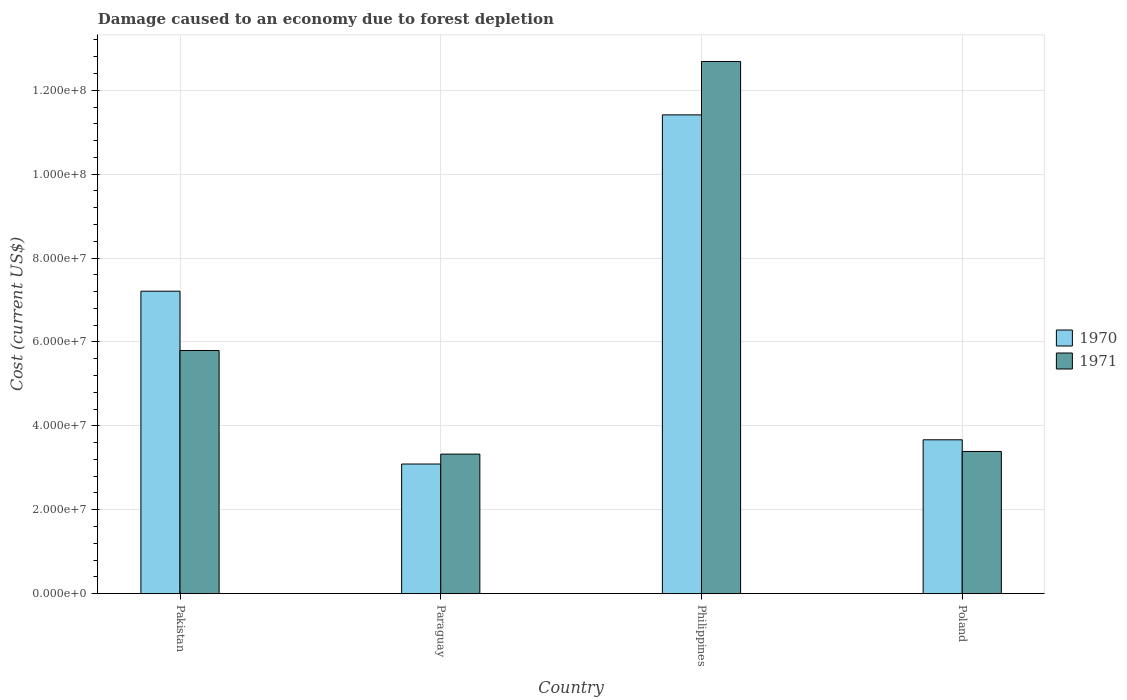Are the number of bars on each tick of the X-axis equal?
Your answer should be very brief. Yes. How many bars are there on the 2nd tick from the left?
Your response must be concise. 2. How many bars are there on the 1st tick from the right?
Provide a short and direct response. 2. What is the label of the 3rd group of bars from the left?
Your answer should be very brief. Philippines. What is the cost of damage caused due to forest depletion in 1971 in Paraguay?
Offer a very short reply. 3.33e+07. Across all countries, what is the maximum cost of damage caused due to forest depletion in 1971?
Provide a short and direct response. 1.27e+08. Across all countries, what is the minimum cost of damage caused due to forest depletion in 1970?
Offer a very short reply. 3.09e+07. In which country was the cost of damage caused due to forest depletion in 1971 minimum?
Keep it short and to the point. Paraguay. What is the total cost of damage caused due to forest depletion in 1971 in the graph?
Ensure brevity in your answer.  2.52e+08. What is the difference between the cost of damage caused due to forest depletion in 1971 in Pakistan and that in Philippines?
Provide a short and direct response. -6.89e+07. What is the difference between the cost of damage caused due to forest depletion in 1970 in Poland and the cost of damage caused due to forest depletion in 1971 in Pakistan?
Provide a succinct answer. -2.13e+07. What is the average cost of damage caused due to forest depletion in 1970 per country?
Make the answer very short. 6.35e+07. What is the difference between the cost of damage caused due to forest depletion of/in 1970 and cost of damage caused due to forest depletion of/in 1971 in Paraguay?
Provide a short and direct response. -2.36e+06. In how many countries, is the cost of damage caused due to forest depletion in 1970 greater than 64000000 US$?
Provide a succinct answer. 2. What is the ratio of the cost of damage caused due to forest depletion in 1970 in Pakistan to that in Philippines?
Offer a very short reply. 0.63. Is the cost of damage caused due to forest depletion in 1970 in Paraguay less than that in Philippines?
Provide a succinct answer. Yes. What is the difference between the highest and the second highest cost of damage caused due to forest depletion in 1971?
Provide a succinct answer. -6.89e+07. What is the difference between the highest and the lowest cost of damage caused due to forest depletion in 1970?
Keep it short and to the point. 8.32e+07. Is the sum of the cost of damage caused due to forest depletion in 1971 in Pakistan and Paraguay greater than the maximum cost of damage caused due to forest depletion in 1970 across all countries?
Keep it short and to the point. No. What does the 1st bar from the left in Pakistan represents?
Give a very brief answer. 1970. How many bars are there?
Keep it short and to the point. 8. Are all the bars in the graph horizontal?
Give a very brief answer. No. How many countries are there in the graph?
Your answer should be compact. 4. What is the difference between two consecutive major ticks on the Y-axis?
Offer a terse response. 2.00e+07. Are the values on the major ticks of Y-axis written in scientific E-notation?
Give a very brief answer. Yes. How are the legend labels stacked?
Offer a terse response. Vertical. What is the title of the graph?
Ensure brevity in your answer.  Damage caused to an economy due to forest depletion. What is the label or title of the X-axis?
Give a very brief answer. Country. What is the label or title of the Y-axis?
Give a very brief answer. Cost (current US$). What is the Cost (current US$) in 1970 in Pakistan?
Your answer should be very brief. 7.21e+07. What is the Cost (current US$) of 1971 in Pakistan?
Provide a short and direct response. 5.80e+07. What is the Cost (current US$) of 1970 in Paraguay?
Provide a succinct answer. 3.09e+07. What is the Cost (current US$) in 1971 in Paraguay?
Provide a succinct answer. 3.33e+07. What is the Cost (current US$) of 1970 in Philippines?
Offer a very short reply. 1.14e+08. What is the Cost (current US$) of 1971 in Philippines?
Provide a short and direct response. 1.27e+08. What is the Cost (current US$) in 1970 in Poland?
Provide a short and direct response. 3.67e+07. What is the Cost (current US$) of 1971 in Poland?
Provide a short and direct response. 3.39e+07. Across all countries, what is the maximum Cost (current US$) of 1970?
Your answer should be very brief. 1.14e+08. Across all countries, what is the maximum Cost (current US$) of 1971?
Your response must be concise. 1.27e+08. Across all countries, what is the minimum Cost (current US$) of 1970?
Offer a very short reply. 3.09e+07. Across all countries, what is the minimum Cost (current US$) of 1971?
Your answer should be very brief. 3.33e+07. What is the total Cost (current US$) of 1970 in the graph?
Offer a terse response. 2.54e+08. What is the total Cost (current US$) of 1971 in the graph?
Offer a terse response. 2.52e+08. What is the difference between the Cost (current US$) in 1970 in Pakistan and that in Paraguay?
Ensure brevity in your answer.  4.12e+07. What is the difference between the Cost (current US$) in 1971 in Pakistan and that in Paraguay?
Provide a short and direct response. 2.47e+07. What is the difference between the Cost (current US$) of 1970 in Pakistan and that in Philippines?
Ensure brevity in your answer.  -4.20e+07. What is the difference between the Cost (current US$) in 1971 in Pakistan and that in Philippines?
Your answer should be very brief. -6.89e+07. What is the difference between the Cost (current US$) of 1970 in Pakistan and that in Poland?
Your response must be concise. 3.54e+07. What is the difference between the Cost (current US$) of 1971 in Pakistan and that in Poland?
Your answer should be compact. 2.41e+07. What is the difference between the Cost (current US$) of 1970 in Paraguay and that in Philippines?
Your answer should be very brief. -8.32e+07. What is the difference between the Cost (current US$) of 1971 in Paraguay and that in Philippines?
Offer a terse response. -9.36e+07. What is the difference between the Cost (current US$) of 1970 in Paraguay and that in Poland?
Provide a succinct answer. -5.78e+06. What is the difference between the Cost (current US$) of 1971 in Paraguay and that in Poland?
Give a very brief answer. -6.33e+05. What is the difference between the Cost (current US$) of 1970 in Philippines and that in Poland?
Your answer should be very brief. 7.75e+07. What is the difference between the Cost (current US$) of 1971 in Philippines and that in Poland?
Your response must be concise. 9.30e+07. What is the difference between the Cost (current US$) of 1970 in Pakistan and the Cost (current US$) of 1971 in Paraguay?
Offer a very short reply. 3.88e+07. What is the difference between the Cost (current US$) of 1970 in Pakistan and the Cost (current US$) of 1971 in Philippines?
Make the answer very short. -5.48e+07. What is the difference between the Cost (current US$) in 1970 in Pakistan and the Cost (current US$) in 1971 in Poland?
Keep it short and to the point. 3.82e+07. What is the difference between the Cost (current US$) of 1970 in Paraguay and the Cost (current US$) of 1971 in Philippines?
Make the answer very short. -9.60e+07. What is the difference between the Cost (current US$) in 1970 in Paraguay and the Cost (current US$) in 1971 in Poland?
Make the answer very short. -3.00e+06. What is the difference between the Cost (current US$) of 1970 in Philippines and the Cost (current US$) of 1971 in Poland?
Keep it short and to the point. 8.02e+07. What is the average Cost (current US$) in 1970 per country?
Provide a succinct answer. 6.35e+07. What is the average Cost (current US$) of 1971 per country?
Provide a short and direct response. 6.30e+07. What is the difference between the Cost (current US$) in 1970 and Cost (current US$) in 1971 in Pakistan?
Your answer should be very brief. 1.41e+07. What is the difference between the Cost (current US$) in 1970 and Cost (current US$) in 1971 in Paraguay?
Your response must be concise. -2.36e+06. What is the difference between the Cost (current US$) of 1970 and Cost (current US$) of 1971 in Philippines?
Provide a succinct answer. -1.27e+07. What is the difference between the Cost (current US$) of 1970 and Cost (current US$) of 1971 in Poland?
Offer a terse response. 2.78e+06. What is the ratio of the Cost (current US$) of 1970 in Pakistan to that in Paraguay?
Offer a very short reply. 2.33. What is the ratio of the Cost (current US$) of 1971 in Pakistan to that in Paraguay?
Your answer should be very brief. 1.74. What is the ratio of the Cost (current US$) of 1970 in Pakistan to that in Philippines?
Your response must be concise. 0.63. What is the ratio of the Cost (current US$) of 1971 in Pakistan to that in Philippines?
Your answer should be very brief. 0.46. What is the ratio of the Cost (current US$) of 1970 in Pakistan to that in Poland?
Provide a succinct answer. 1.97. What is the ratio of the Cost (current US$) of 1971 in Pakistan to that in Poland?
Make the answer very short. 1.71. What is the ratio of the Cost (current US$) in 1970 in Paraguay to that in Philippines?
Your response must be concise. 0.27. What is the ratio of the Cost (current US$) in 1971 in Paraguay to that in Philippines?
Your response must be concise. 0.26. What is the ratio of the Cost (current US$) of 1970 in Paraguay to that in Poland?
Provide a succinct answer. 0.84. What is the ratio of the Cost (current US$) of 1971 in Paraguay to that in Poland?
Give a very brief answer. 0.98. What is the ratio of the Cost (current US$) in 1970 in Philippines to that in Poland?
Ensure brevity in your answer.  3.11. What is the ratio of the Cost (current US$) of 1971 in Philippines to that in Poland?
Keep it short and to the point. 3.74. What is the difference between the highest and the second highest Cost (current US$) of 1970?
Your response must be concise. 4.20e+07. What is the difference between the highest and the second highest Cost (current US$) in 1971?
Offer a terse response. 6.89e+07. What is the difference between the highest and the lowest Cost (current US$) in 1970?
Ensure brevity in your answer.  8.32e+07. What is the difference between the highest and the lowest Cost (current US$) of 1971?
Give a very brief answer. 9.36e+07. 